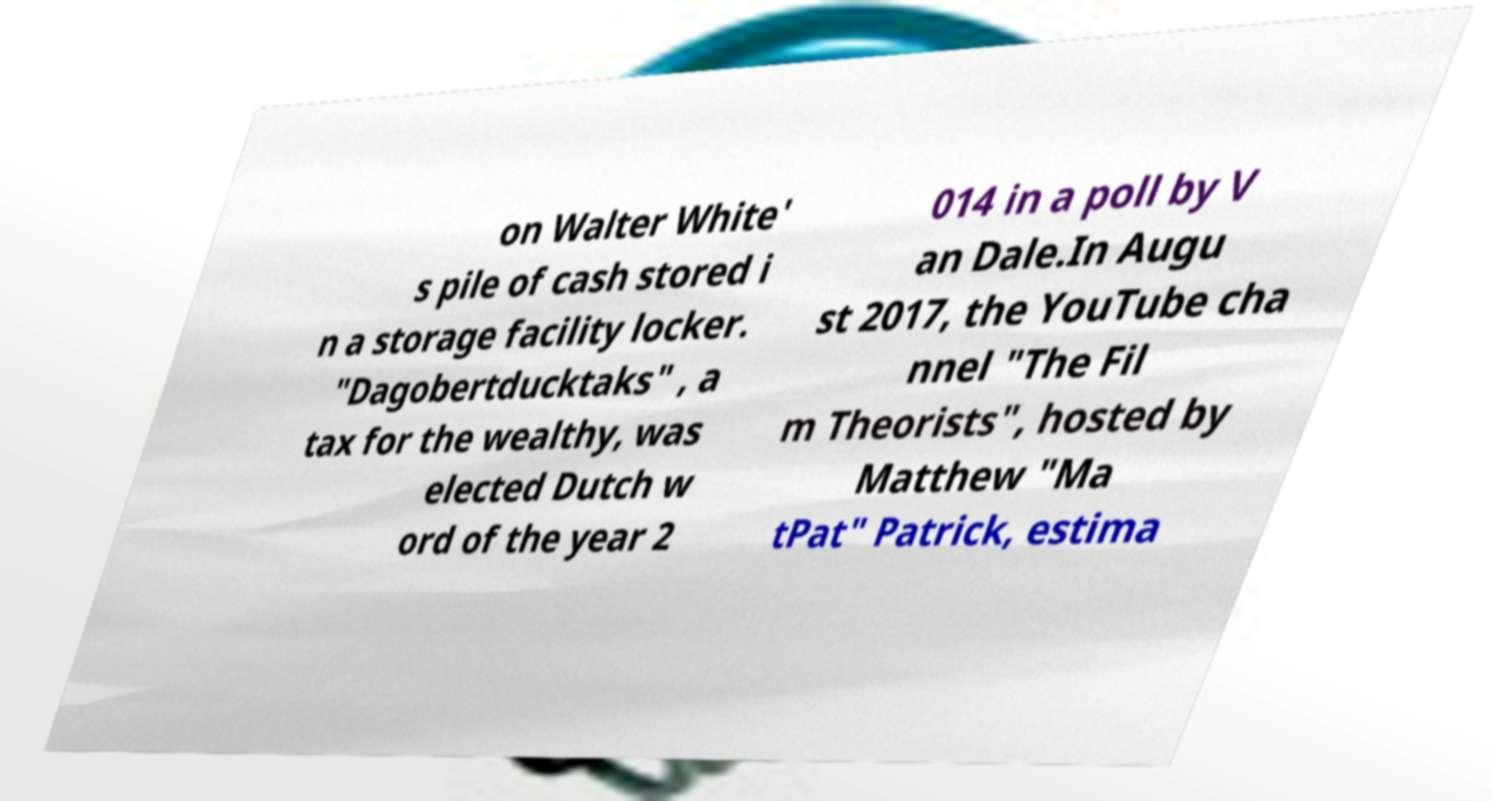I need the written content from this picture converted into text. Can you do that? on Walter White' s pile of cash stored i n a storage facility locker. "Dagobertducktaks" , a tax for the wealthy, was elected Dutch w ord of the year 2 014 in a poll by V an Dale.In Augu st 2017, the YouTube cha nnel "The Fil m Theorists", hosted by Matthew "Ma tPat" Patrick, estima 